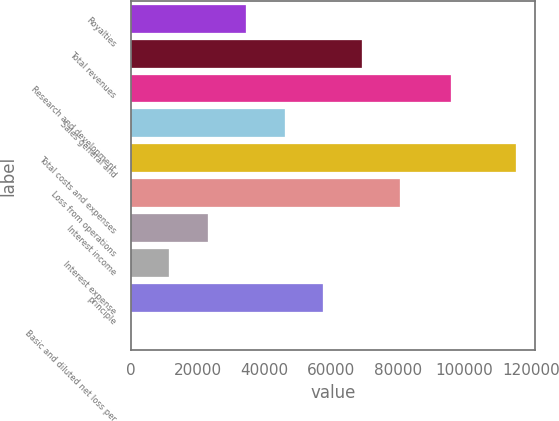Convert chart. <chart><loc_0><loc_0><loc_500><loc_500><bar_chart><fcel>Royalties<fcel>Total revenues<fcel>Research and development<fcel>Sales general and<fcel>Total costs and expenses<fcel>Loss from operations<fcel>Interest income<fcel>Interest expense<fcel>principle<fcel>Basic and diluted net loss per<nl><fcel>34625.1<fcel>69249.8<fcel>96115<fcel>46166.7<fcel>115416<fcel>80791.3<fcel>23083.6<fcel>11542<fcel>57708.2<fcel>0.46<nl></chart> 